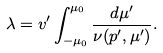Convert formula to latex. <formula><loc_0><loc_0><loc_500><loc_500>\lambda = v ^ { \prime } \int ^ { \mu _ { 0 } } _ { - \mu _ { 0 } } \frac { d \mu ^ { \prime } } { \nu ( p ^ { \prime } , \mu ^ { \prime } ) } .</formula> 